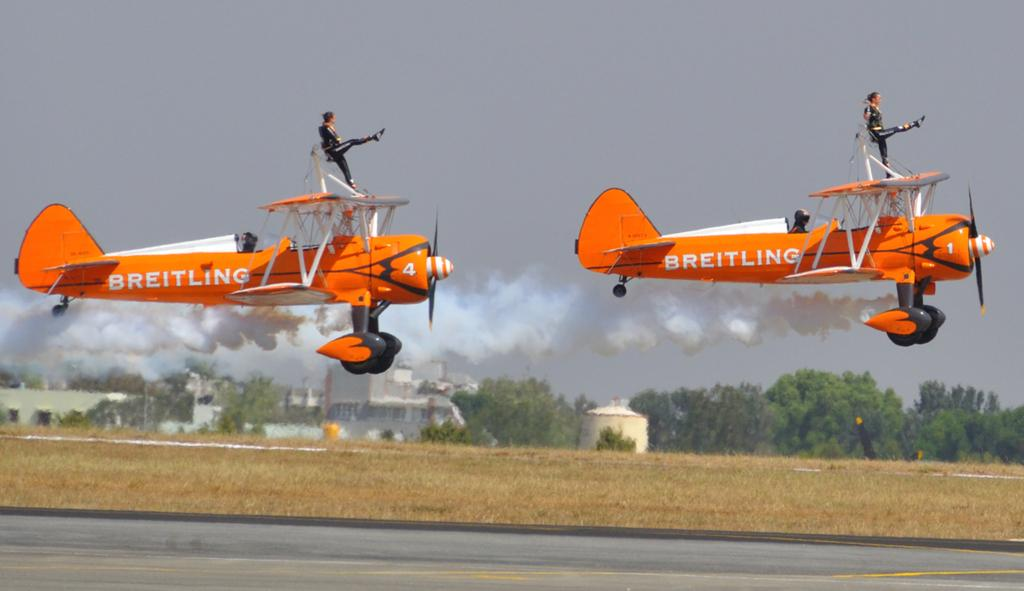<image>
Present a compact description of the photo's key features. Two Breitling aerobatics planes with girls performing on top of them 